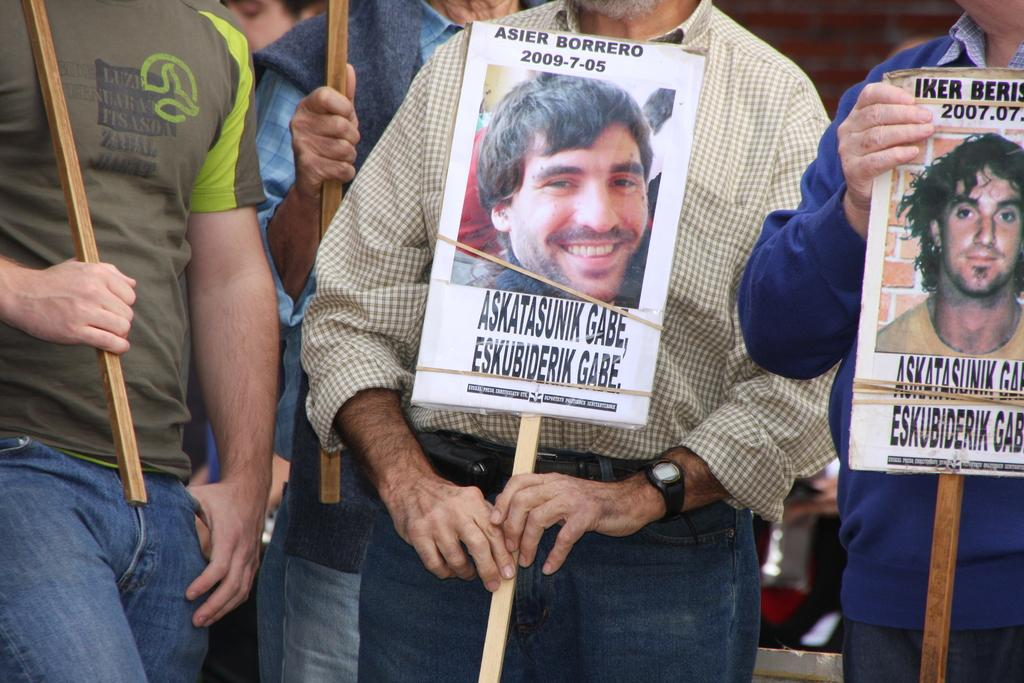Who or what is present in the image? There are people in the image. Where are the people located in the image? The people are in the center of the image. What are the people holding in their hands? The people are holding posters in their hands. What type of substance is being pulled by the people in the image? There is no substance being pulled by the people in the image; they are holding posters in their hands. Is there a church visible in the image? There is no mention of a church in the provided facts, so we cannot determine if one is present in the image. 